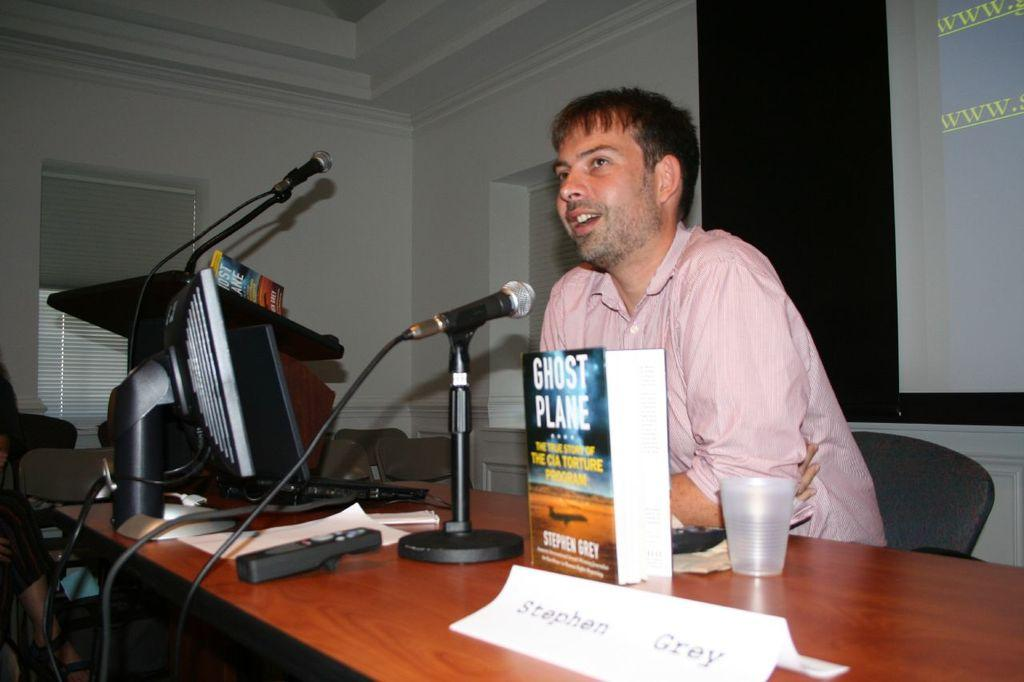What is the person in the image doing? The person is sitting on a chair and talking. What objects are in front of the person? There is a book, a glass, a microphone, and a system (possibly a computer or audio equipment) in front of the person. What might the person be using the microphone for? The person might be using the microphone for recording or amplifying their voice. What could the system in front of the person be used for? The system in front of the person could be used for recording, playing audio, or controlling the microphone. What type of canvas is the maid using to paint in the image? There is no canvas or maid present in the image. What is the cast doing in the image? There is no cast present in the image. 